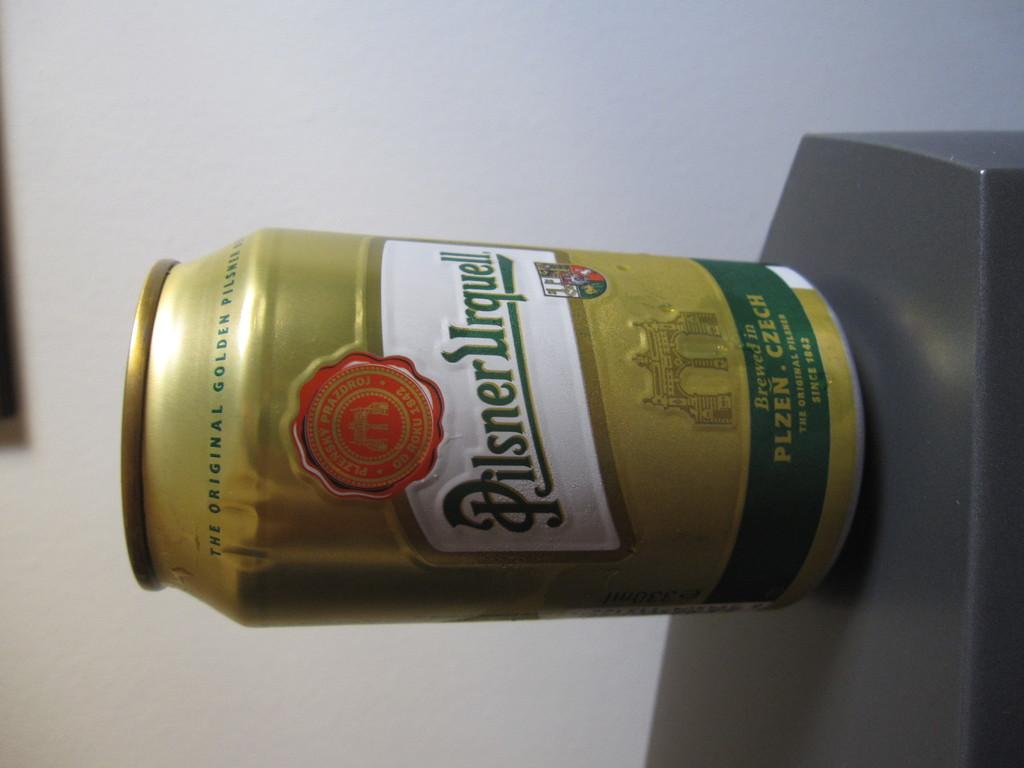<image>
Render a clear and concise summary of the photo. A gold can of Pilsner is shown on a table sideways. 